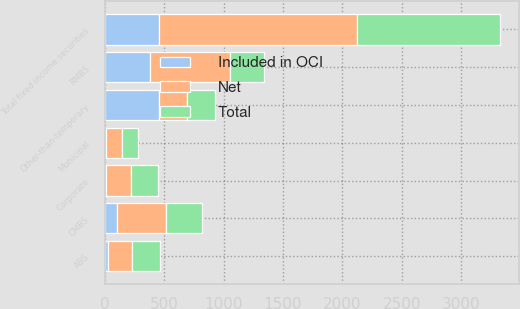Convert chart to OTSL. <chart><loc_0><loc_0><loc_500><loc_500><stacked_bar_chart><ecel><fcel>Municipal<fcel>Corporate<fcel>RMBS<fcel>CMBS<fcel>ABS<fcel>Total fixed income securities<fcel>Other-than-temporary<nl><fcel>Net<fcel>140<fcel>213<fcel>672<fcel>411<fcel>208<fcel>1661<fcel>234<nl><fcel>Included in OCI<fcel>10<fcel>13<fcel>384<fcel>102<fcel>26<fcel>457<fcel>457<nl><fcel>Total<fcel>130<fcel>226<fcel>288<fcel>309<fcel>234<fcel>1204<fcel>234<nl></chart> 